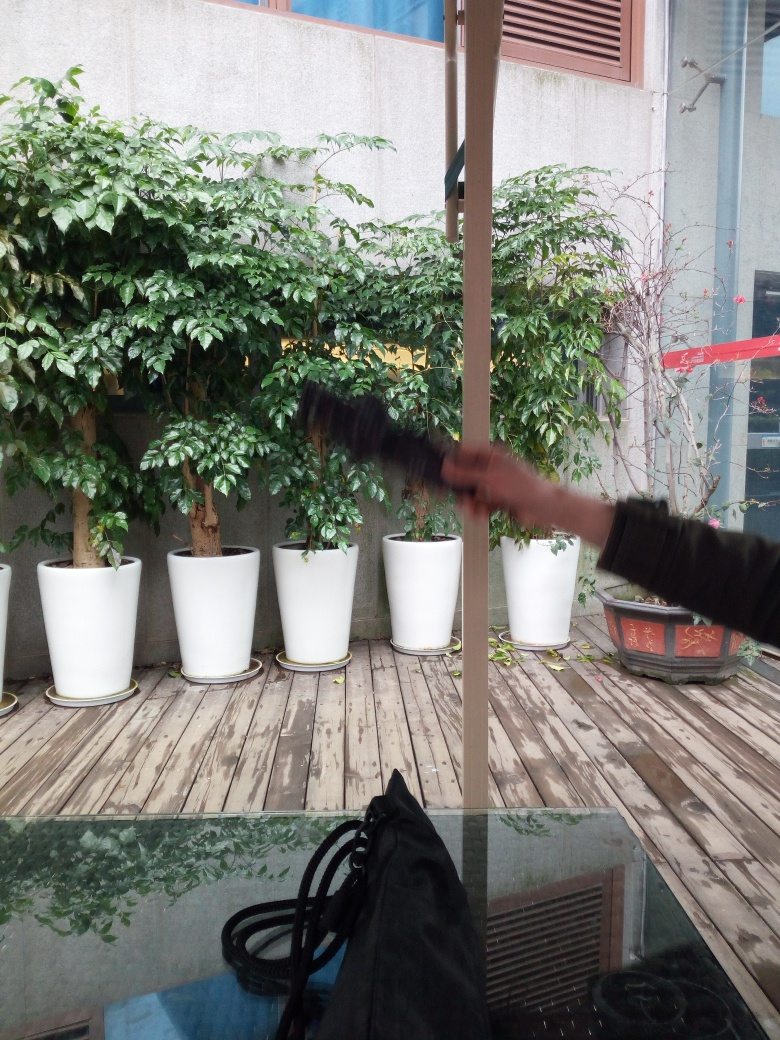What might be the function of the glass panel on the floor? The glass panel could serve as a skylight for a space below, providing natural light to an interior room. It might also be an architectural feature meant to visually connect the two spaces. Is there anything below that can be seen through it? From this angle, it's not possible to clearly discern details through the glass panel, but it does reflect some of the surrounding plants and material, which indicates it might be overlooking an area with similar elements. 